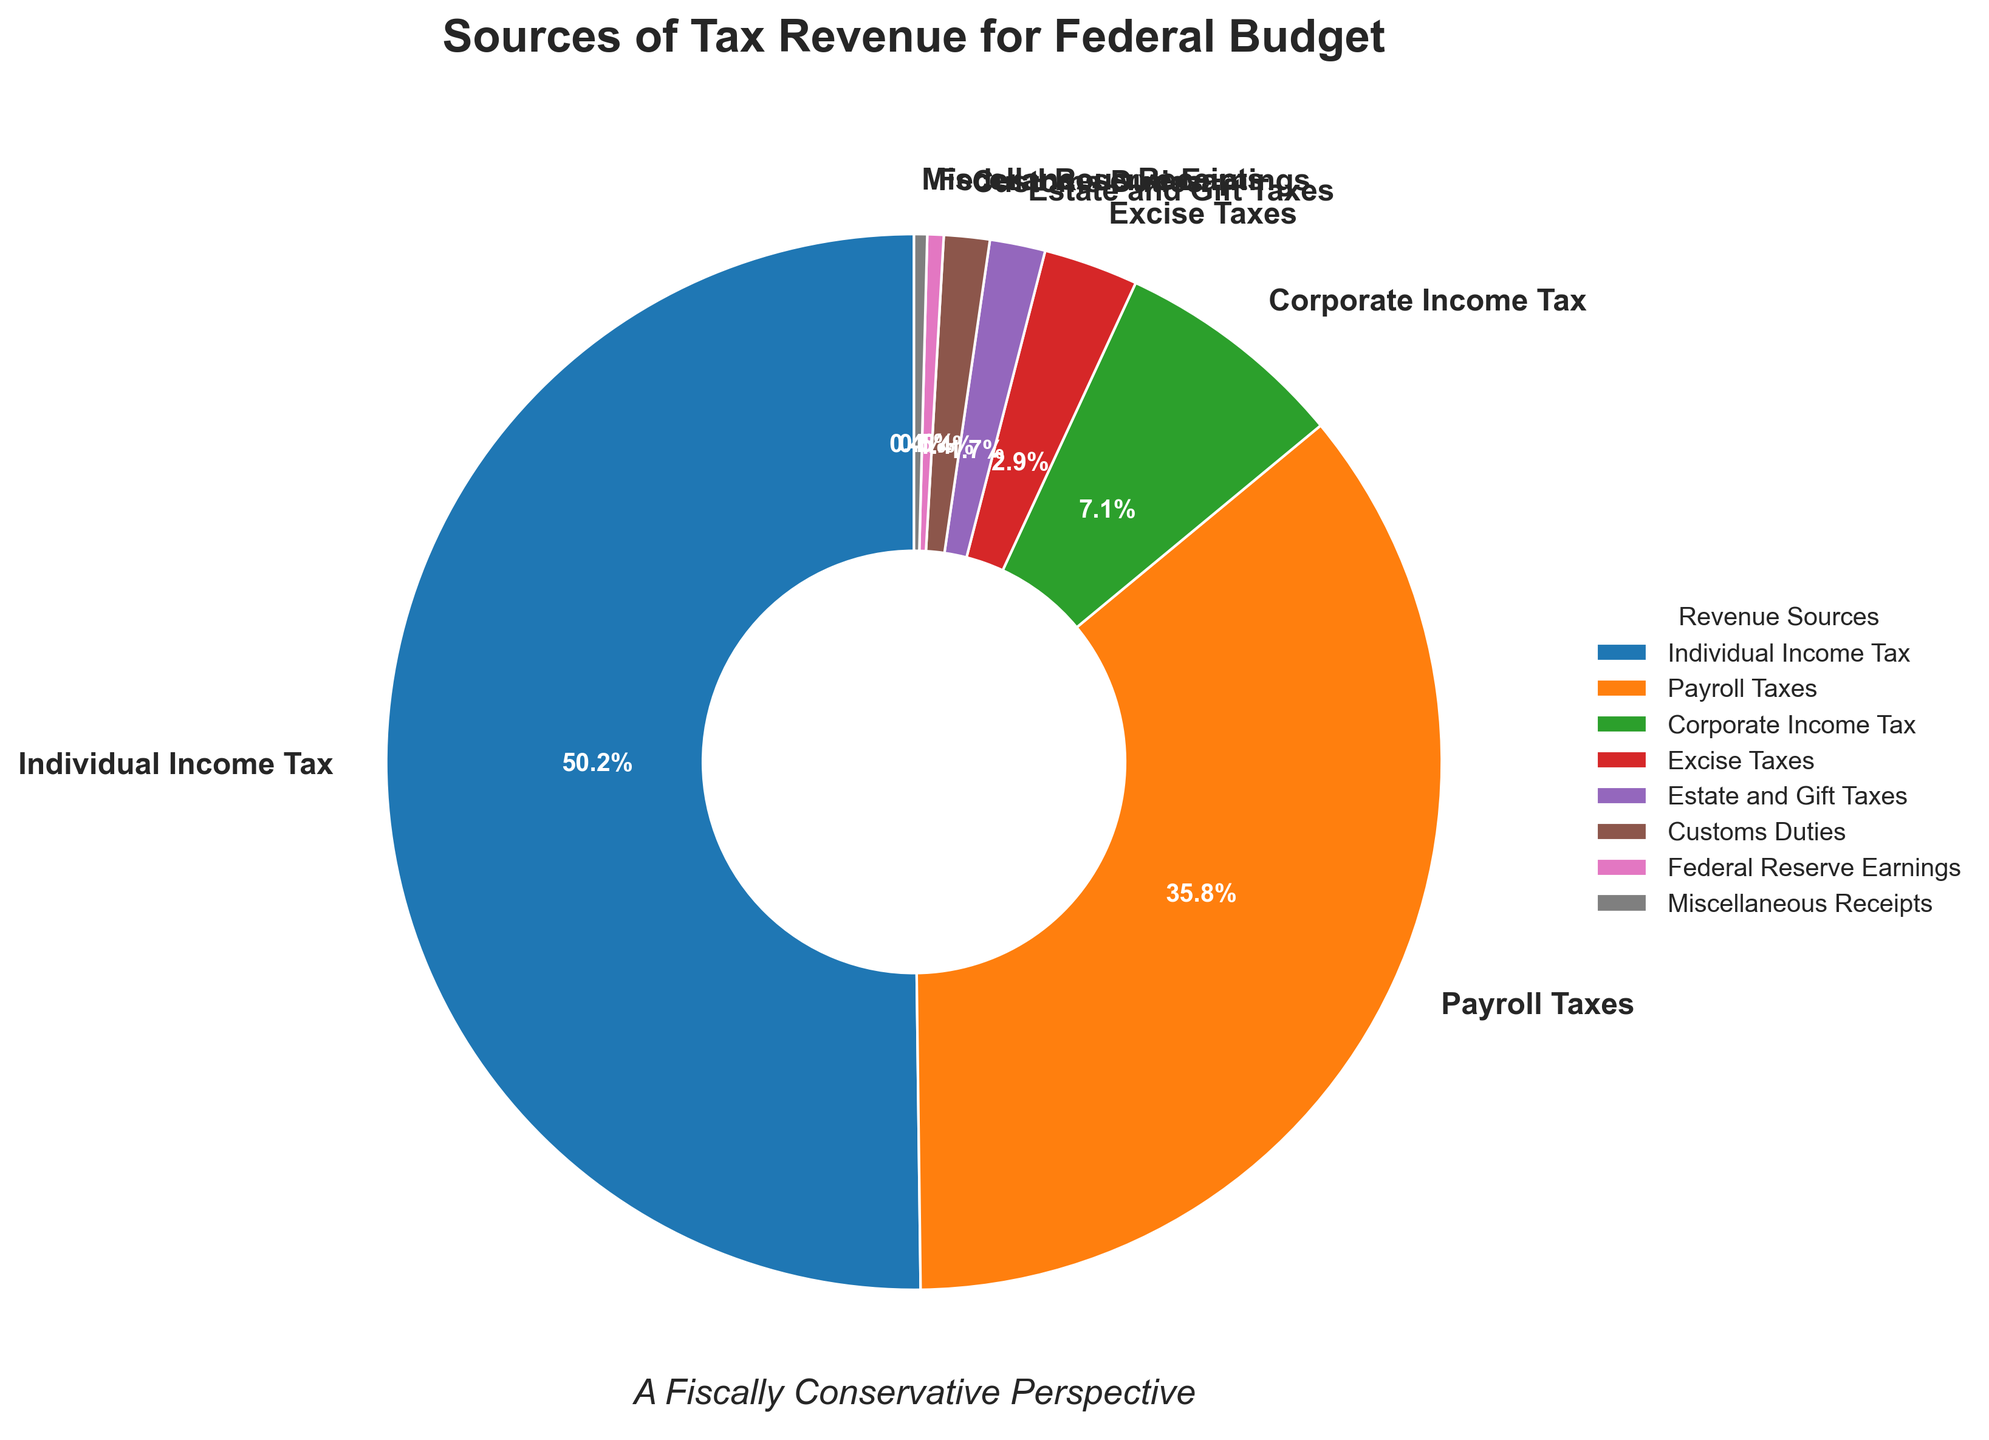what is the combined percentage of Individual Income Tax and Payroll Taxes? Add the percentages of Individual Income Tax (50.2%) and Payroll Taxes (35.8%): 50.2 + 35.8 = 86.
Answer: 86% which tax source contributes the smallest percentage? Among the listed sources, Miscellaneous Receipts contribute the smallest percentage at 0.4%.
Answer: Miscellaneous Receipts how does the percentage of Corporate Income Tax compare to Excise Taxes? Corporate Income Tax is 7.1% while Excise Taxes are 2.9%. Therefore, Corporate Income Tax is higher than Excise Taxes.
Answer: Corporate Income Tax is higher What is the sum of the percentages of Estate and Gift Taxes, and Customs Duties? Estate and Gift Taxes contribute 1.7% and Customs Duties contribute 1.4%. Adding these yields 1.7 + 1.4 = 3.1%.
Answer: 3.1% What percentage of tax revenue is sourced from Federal Reserve Earnings and Miscellaneous Receipts compared to Payroll Taxes? Federal Reserve Earnings and Miscellaneous Receipts combined sum up to 0.5% + 0.4% = 0.9%. Payroll Taxes alone contribute 35.8%. 35.8% is substantially higher than 0.9%.
Answer: Payroll Taxes are higher what are the three largest sources of tax revenue? The top three sources by percentage are Individual Income Tax (50.2%), Payroll Taxes (35.8%), and Corporate Income Tax (7.1%).
Answer: Individual Income Tax, Payroll Taxes, and Corporate Income Tax Which revenue source occupies slightly less than Corporate Income Tax on the pie chart? Excise Taxes, at 2.9%, occupy slightly less space than Corporate Income Tax, which is 7.1%.
Answer: Excise Taxes What is the difference in percentage points between Individual Income Tax and Estate and Gift Taxes? Individual Income Tax is 50.2% and Estate and Gift Taxes are 1.7%. The difference is 50.2 - 1.7 = 48.5 percentage points.
Answer: 48.5 percentage points How does the sum of percentages of the smallest four tax sources compare to Corporate Income Tax? The smallest four sources are Estate and Gift Taxes (1.7%), Customs Duties (1.4%), Federal Reserve Earnings (0.5%), and Miscellaneous Receipts (0.4%), summing up to 1.7 + 1.4 + 0.5 + 0.4 = 4%. Corporate Income Tax is 7.1%. 7.1% is greater than 4%.
Answer: Corporate Income Tax is higher 